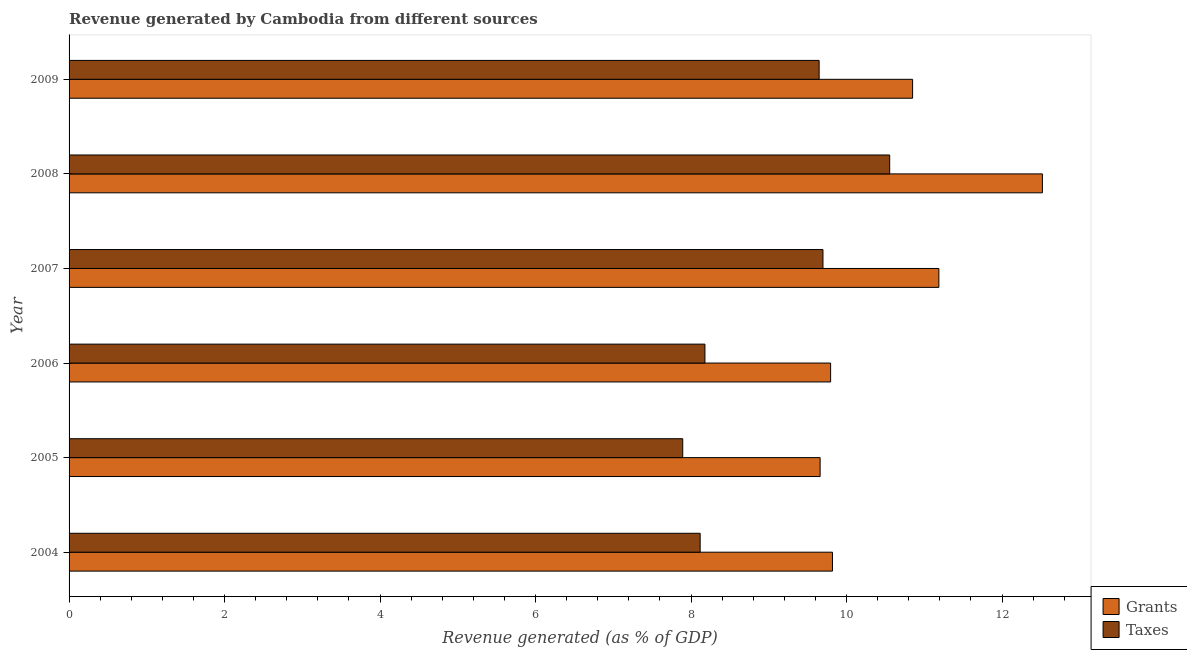How many groups of bars are there?
Offer a very short reply. 6. How many bars are there on the 6th tick from the bottom?
Provide a succinct answer. 2. What is the revenue generated by grants in 2005?
Provide a short and direct response. 9.66. Across all years, what is the maximum revenue generated by taxes?
Provide a succinct answer. 10.56. Across all years, what is the minimum revenue generated by taxes?
Ensure brevity in your answer.  7.89. In which year was the revenue generated by grants minimum?
Keep it short and to the point. 2005. What is the total revenue generated by grants in the graph?
Offer a very short reply. 63.83. What is the difference between the revenue generated by grants in 2004 and that in 2005?
Make the answer very short. 0.16. What is the difference between the revenue generated by grants in 2006 and the revenue generated by taxes in 2007?
Offer a very short reply. 0.1. What is the average revenue generated by grants per year?
Provide a succinct answer. 10.64. In the year 2009, what is the difference between the revenue generated by taxes and revenue generated by grants?
Your response must be concise. -1.2. What is the ratio of the revenue generated by taxes in 2007 to that in 2008?
Offer a terse response. 0.92. What is the difference between the highest and the second highest revenue generated by taxes?
Offer a terse response. 0.86. What is the difference between the highest and the lowest revenue generated by grants?
Your response must be concise. 2.86. In how many years, is the revenue generated by grants greater than the average revenue generated by grants taken over all years?
Provide a short and direct response. 3. What does the 1st bar from the top in 2005 represents?
Offer a very short reply. Taxes. What does the 2nd bar from the bottom in 2008 represents?
Provide a short and direct response. Taxes. Are all the bars in the graph horizontal?
Make the answer very short. Yes. What is the difference between two consecutive major ticks on the X-axis?
Offer a terse response. 2. Are the values on the major ticks of X-axis written in scientific E-notation?
Give a very brief answer. No. Does the graph contain any zero values?
Offer a terse response. No. Does the graph contain grids?
Your answer should be very brief. No. What is the title of the graph?
Provide a short and direct response. Revenue generated by Cambodia from different sources. Does "2012 US$" appear as one of the legend labels in the graph?
Offer a terse response. No. What is the label or title of the X-axis?
Offer a terse response. Revenue generated (as % of GDP). What is the Revenue generated (as % of GDP) in Grants in 2004?
Your answer should be very brief. 9.82. What is the Revenue generated (as % of GDP) in Taxes in 2004?
Your answer should be very brief. 8.12. What is the Revenue generated (as % of GDP) of Grants in 2005?
Provide a short and direct response. 9.66. What is the Revenue generated (as % of GDP) in Taxes in 2005?
Ensure brevity in your answer.  7.89. What is the Revenue generated (as % of GDP) in Grants in 2006?
Keep it short and to the point. 9.8. What is the Revenue generated (as % of GDP) of Taxes in 2006?
Your response must be concise. 8.18. What is the Revenue generated (as % of GDP) of Grants in 2007?
Offer a terse response. 11.19. What is the Revenue generated (as % of GDP) of Taxes in 2007?
Make the answer very short. 9.7. What is the Revenue generated (as % of GDP) of Grants in 2008?
Offer a very short reply. 12.52. What is the Revenue generated (as % of GDP) of Taxes in 2008?
Your response must be concise. 10.56. What is the Revenue generated (as % of GDP) in Grants in 2009?
Make the answer very short. 10.85. What is the Revenue generated (as % of GDP) in Taxes in 2009?
Make the answer very short. 9.65. Across all years, what is the maximum Revenue generated (as % of GDP) of Grants?
Offer a very short reply. 12.52. Across all years, what is the maximum Revenue generated (as % of GDP) of Taxes?
Offer a very short reply. 10.56. Across all years, what is the minimum Revenue generated (as % of GDP) in Grants?
Provide a succinct answer. 9.66. Across all years, what is the minimum Revenue generated (as % of GDP) in Taxes?
Your answer should be compact. 7.89. What is the total Revenue generated (as % of GDP) in Grants in the graph?
Provide a short and direct response. 63.83. What is the total Revenue generated (as % of GDP) in Taxes in the graph?
Ensure brevity in your answer.  54.09. What is the difference between the Revenue generated (as % of GDP) in Grants in 2004 and that in 2005?
Your answer should be compact. 0.16. What is the difference between the Revenue generated (as % of GDP) of Taxes in 2004 and that in 2005?
Keep it short and to the point. 0.22. What is the difference between the Revenue generated (as % of GDP) in Grants in 2004 and that in 2006?
Provide a succinct answer. 0.02. What is the difference between the Revenue generated (as % of GDP) in Taxes in 2004 and that in 2006?
Give a very brief answer. -0.06. What is the difference between the Revenue generated (as % of GDP) of Grants in 2004 and that in 2007?
Your answer should be very brief. -1.37. What is the difference between the Revenue generated (as % of GDP) of Taxes in 2004 and that in 2007?
Make the answer very short. -1.58. What is the difference between the Revenue generated (as % of GDP) in Grants in 2004 and that in 2008?
Make the answer very short. -2.7. What is the difference between the Revenue generated (as % of GDP) in Taxes in 2004 and that in 2008?
Give a very brief answer. -2.44. What is the difference between the Revenue generated (as % of GDP) of Grants in 2004 and that in 2009?
Offer a terse response. -1.03. What is the difference between the Revenue generated (as % of GDP) of Taxes in 2004 and that in 2009?
Offer a terse response. -1.53. What is the difference between the Revenue generated (as % of GDP) of Grants in 2005 and that in 2006?
Offer a very short reply. -0.13. What is the difference between the Revenue generated (as % of GDP) of Taxes in 2005 and that in 2006?
Make the answer very short. -0.29. What is the difference between the Revenue generated (as % of GDP) in Grants in 2005 and that in 2007?
Provide a succinct answer. -1.53. What is the difference between the Revenue generated (as % of GDP) in Taxes in 2005 and that in 2007?
Your answer should be very brief. -1.8. What is the difference between the Revenue generated (as % of GDP) of Grants in 2005 and that in 2008?
Provide a short and direct response. -2.86. What is the difference between the Revenue generated (as % of GDP) of Taxes in 2005 and that in 2008?
Offer a terse response. -2.66. What is the difference between the Revenue generated (as % of GDP) in Grants in 2005 and that in 2009?
Offer a terse response. -1.19. What is the difference between the Revenue generated (as % of GDP) of Taxes in 2005 and that in 2009?
Your response must be concise. -1.75. What is the difference between the Revenue generated (as % of GDP) in Grants in 2006 and that in 2007?
Offer a terse response. -1.39. What is the difference between the Revenue generated (as % of GDP) of Taxes in 2006 and that in 2007?
Make the answer very short. -1.52. What is the difference between the Revenue generated (as % of GDP) in Grants in 2006 and that in 2008?
Ensure brevity in your answer.  -2.72. What is the difference between the Revenue generated (as % of GDP) in Taxes in 2006 and that in 2008?
Give a very brief answer. -2.38. What is the difference between the Revenue generated (as % of GDP) of Grants in 2006 and that in 2009?
Provide a short and direct response. -1.05. What is the difference between the Revenue generated (as % of GDP) in Taxes in 2006 and that in 2009?
Give a very brief answer. -1.47. What is the difference between the Revenue generated (as % of GDP) in Grants in 2007 and that in 2008?
Give a very brief answer. -1.33. What is the difference between the Revenue generated (as % of GDP) in Taxes in 2007 and that in 2008?
Offer a terse response. -0.86. What is the difference between the Revenue generated (as % of GDP) in Grants in 2007 and that in 2009?
Offer a terse response. 0.34. What is the difference between the Revenue generated (as % of GDP) in Taxes in 2007 and that in 2009?
Offer a very short reply. 0.05. What is the difference between the Revenue generated (as % of GDP) in Grants in 2008 and that in 2009?
Provide a succinct answer. 1.67. What is the difference between the Revenue generated (as % of GDP) in Taxes in 2008 and that in 2009?
Give a very brief answer. 0.91. What is the difference between the Revenue generated (as % of GDP) in Grants in 2004 and the Revenue generated (as % of GDP) in Taxes in 2005?
Your response must be concise. 1.93. What is the difference between the Revenue generated (as % of GDP) of Grants in 2004 and the Revenue generated (as % of GDP) of Taxes in 2006?
Offer a terse response. 1.64. What is the difference between the Revenue generated (as % of GDP) in Grants in 2004 and the Revenue generated (as % of GDP) in Taxes in 2007?
Your answer should be very brief. 0.12. What is the difference between the Revenue generated (as % of GDP) in Grants in 2004 and the Revenue generated (as % of GDP) in Taxes in 2008?
Ensure brevity in your answer.  -0.74. What is the difference between the Revenue generated (as % of GDP) of Grants in 2004 and the Revenue generated (as % of GDP) of Taxes in 2009?
Make the answer very short. 0.17. What is the difference between the Revenue generated (as % of GDP) in Grants in 2005 and the Revenue generated (as % of GDP) in Taxes in 2006?
Your answer should be very brief. 1.48. What is the difference between the Revenue generated (as % of GDP) of Grants in 2005 and the Revenue generated (as % of GDP) of Taxes in 2007?
Offer a terse response. -0.04. What is the difference between the Revenue generated (as % of GDP) in Grants in 2005 and the Revenue generated (as % of GDP) in Taxes in 2008?
Provide a succinct answer. -0.89. What is the difference between the Revenue generated (as % of GDP) of Grants in 2005 and the Revenue generated (as % of GDP) of Taxes in 2009?
Provide a short and direct response. 0.01. What is the difference between the Revenue generated (as % of GDP) in Grants in 2006 and the Revenue generated (as % of GDP) in Taxes in 2007?
Provide a succinct answer. 0.1. What is the difference between the Revenue generated (as % of GDP) in Grants in 2006 and the Revenue generated (as % of GDP) in Taxes in 2008?
Give a very brief answer. -0.76. What is the difference between the Revenue generated (as % of GDP) of Grants in 2006 and the Revenue generated (as % of GDP) of Taxes in 2009?
Offer a terse response. 0.15. What is the difference between the Revenue generated (as % of GDP) in Grants in 2007 and the Revenue generated (as % of GDP) in Taxes in 2008?
Ensure brevity in your answer.  0.63. What is the difference between the Revenue generated (as % of GDP) in Grants in 2007 and the Revenue generated (as % of GDP) in Taxes in 2009?
Provide a short and direct response. 1.54. What is the difference between the Revenue generated (as % of GDP) of Grants in 2008 and the Revenue generated (as % of GDP) of Taxes in 2009?
Give a very brief answer. 2.87. What is the average Revenue generated (as % of GDP) of Grants per year?
Provide a short and direct response. 10.64. What is the average Revenue generated (as % of GDP) in Taxes per year?
Ensure brevity in your answer.  9.01. In the year 2004, what is the difference between the Revenue generated (as % of GDP) of Grants and Revenue generated (as % of GDP) of Taxes?
Provide a short and direct response. 1.7. In the year 2005, what is the difference between the Revenue generated (as % of GDP) in Grants and Revenue generated (as % of GDP) in Taxes?
Offer a very short reply. 1.77. In the year 2006, what is the difference between the Revenue generated (as % of GDP) in Grants and Revenue generated (as % of GDP) in Taxes?
Keep it short and to the point. 1.62. In the year 2007, what is the difference between the Revenue generated (as % of GDP) of Grants and Revenue generated (as % of GDP) of Taxes?
Offer a very short reply. 1.49. In the year 2008, what is the difference between the Revenue generated (as % of GDP) in Grants and Revenue generated (as % of GDP) in Taxes?
Give a very brief answer. 1.96. In the year 2009, what is the difference between the Revenue generated (as % of GDP) in Grants and Revenue generated (as % of GDP) in Taxes?
Provide a short and direct response. 1.2. What is the ratio of the Revenue generated (as % of GDP) of Grants in 2004 to that in 2005?
Offer a very short reply. 1.02. What is the ratio of the Revenue generated (as % of GDP) of Taxes in 2004 to that in 2005?
Offer a terse response. 1.03. What is the ratio of the Revenue generated (as % of GDP) in Grants in 2004 to that in 2006?
Your response must be concise. 1. What is the ratio of the Revenue generated (as % of GDP) of Taxes in 2004 to that in 2006?
Keep it short and to the point. 0.99. What is the ratio of the Revenue generated (as % of GDP) of Grants in 2004 to that in 2007?
Provide a succinct answer. 0.88. What is the ratio of the Revenue generated (as % of GDP) of Taxes in 2004 to that in 2007?
Your answer should be very brief. 0.84. What is the ratio of the Revenue generated (as % of GDP) in Grants in 2004 to that in 2008?
Ensure brevity in your answer.  0.78. What is the ratio of the Revenue generated (as % of GDP) in Taxes in 2004 to that in 2008?
Make the answer very short. 0.77. What is the ratio of the Revenue generated (as % of GDP) of Grants in 2004 to that in 2009?
Offer a terse response. 0.91. What is the ratio of the Revenue generated (as % of GDP) of Taxes in 2004 to that in 2009?
Provide a succinct answer. 0.84. What is the ratio of the Revenue generated (as % of GDP) in Grants in 2005 to that in 2006?
Your answer should be very brief. 0.99. What is the ratio of the Revenue generated (as % of GDP) of Taxes in 2005 to that in 2006?
Provide a succinct answer. 0.97. What is the ratio of the Revenue generated (as % of GDP) in Grants in 2005 to that in 2007?
Keep it short and to the point. 0.86. What is the ratio of the Revenue generated (as % of GDP) in Taxes in 2005 to that in 2007?
Ensure brevity in your answer.  0.81. What is the ratio of the Revenue generated (as % of GDP) in Grants in 2005 to that in 2008?
Your answer should be compact. 0.77. What is the ratio of the Revenue generated (as % of GDP) of Taxes in 2005 to that in 2008?
Your answer should be compact. 0.75. What is the ratio of the Revenue generated (as % of GDP) of Grants in 2005 to that in 2009?
Offer a terse response. 0.89. What is the ratio of the Revenue generated (as % of GDP) of Taxes in 2005 to that in 2009?
Give a very brief answer. 0.82. What is the ratio of the Revenue generated (as % of GDP) in Grants in 2006 to that in 2007?
Offer a very short reply. 0.88. What is the ratio of the Revenue generated (as % of GDP) of Taxes in 2006 to that in 2007?
Offer a terse response. 0.84. What is the ratio of the Revenue generated (as % of GDP) of Grants in 2006 to that in 2008?
Offer a terse response. 0.78. What is the ratio of the Revenue generated (as % of GDP) of Taxes in 2006 to that in 2008?
Ensure brevity in your answer.  0.77. What is the ratio of the Revenue generated (as % of GDP) of Grants in 2006 to that in 2009?
Your answer should be compact. 0.9. What is the ratio of the Revenue generated (as % of GDP) of Taxes in 2006 to that in 2009?
Your response must be concise. 0.85. What is the ratio of the Revenue generated (as % of GDP) of Grants in 2007 to that in 2008?
Offer a terse response. 0.89. What is the ratio of the Revenue generated (as % of GDP) in Taxes in 2007 to that in 2008?
Ensure brevity in your answer.  0.92. What is the ratio of the Revenue generated (as % of GDP) of Grants in 2007 to that in 2009?
Give a very brief answer. 1.03. What is the ratio of the Revenue generated (as % of GDP) of Grants in 2008 to that in 2009?
Keep it short and to the point. 1.15. What is the ratio of the Revenue generated (as % of GDP) in Taxes in 2008 to that in 2009?
Offer a very short reply. 1.09. What is the difference between the highest and the second highest Revenue generated (as % of GDP) in Grants?
Make the answer very short. 1.33. What is the difference between the highest and the second highest Revenue generated (as % of GDP) in Taxes?
Make the answer very short. 0.86. What is the difference between the highest and the lowest Revenue generated (as % of GDP) in Grants?
Ensure brevity in your answer.  2.86. What is the difference between the highest and the lowest Revenue generated (as % of GDP) in Taxes?
Make the answer very short. 2.66. 